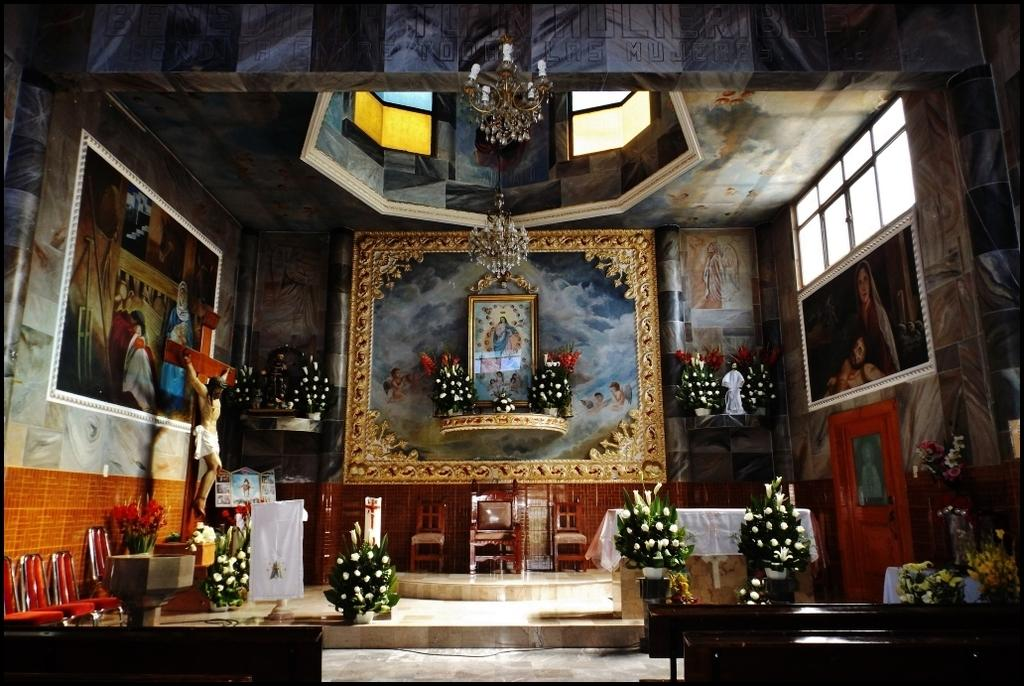Where was the image taken? The image was taken inside a church. What can be observed about the walls in the image? The walls in the image are beautiful. What is hanging on the walls in the image? There are photo frames on the walls in the image. What type of seating is present in the image? There are chairs and benches in the image. Are there any objects related to reading in the image? Yes, there is at least one book in the image. Can you see a snail crawling on the land in the image? There is no snail or land visible in the image, as it was taken inside a church. 